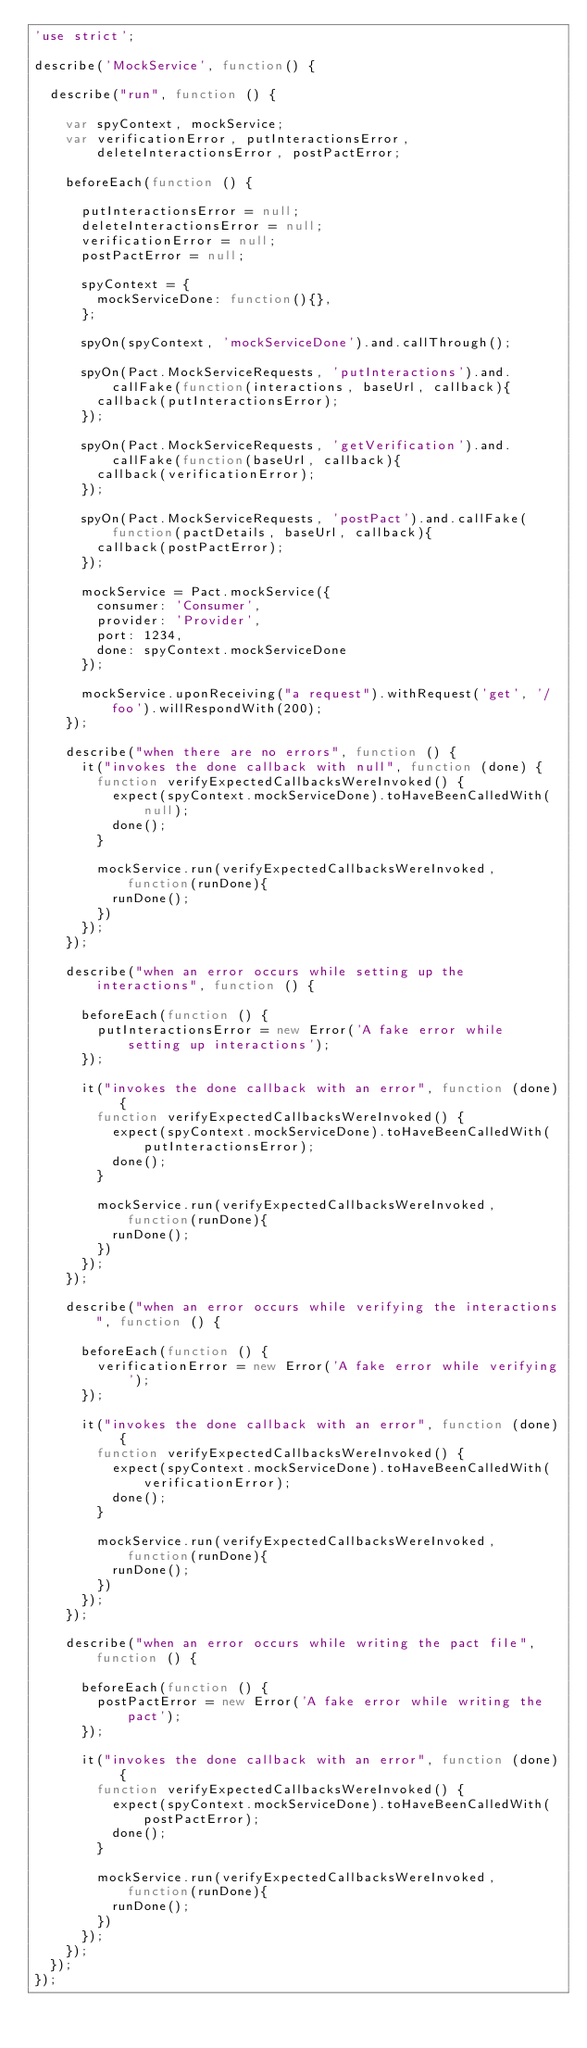Convert code to text. <code><loc_0><loc_0><loc_500><loc_500><_JavaScript_>'use strict';

describe('MockService', function() {

  describe("run", function () {

    var spyContext, mockService;
    var verificationError, putInteractionsError, deleteInteractionsError, postPactError;

    beforeEach(function () {

      putInteractionsError = null;
      deleteInteractionsError = null;
      verificationError = null;
      postPactError = null;

      spyContext = {
        mockServiceDone: function(){},
      };

      spyOn(spyContext, 'mockServiceDone').and.callThrough();

      spyOn(Pact.MockServiceRequests, 'putInteractions').and.callFake(function(interactions, baseUrl, callback){
        callback(putInteractionsError);
      });

      spyOn(Pact.MockServiceRequests, 'getVerification').and.callFake(function(baseUrl, callback){
        callback(verificationError);
      });

      spyOn(Pact.MockServiceRequests, 'postPact').and.callFake(function(pactDetails, baseUrl, callback){
        callback(postPactError);
      });

      mockService = Pact.mockService({
        consumer: 'Consumer',
        provider: 'Provider',
        port: 1234,
        done: spyContext.mockServiceDone
      });

      mockService.uponReceiving("a request").withRequest('get', '/foo').willRespondWith(200);
    });

    describe("when there are no errors", function () {
      it("invokes the done callback with null", function (done) {
        function verifyExpectedCallbacksWereInvoked() {
          expect(spyContext.mockServiceDone).toHaveBeenCalledWith(null);
          done();
        }

        mockService.run(verifyExpectedCallbacksWereInvoked, function(runDone){
          runDone();
        })
      });
    });

    describe("when an error occurs while setting up the interactions", function () {

      beforeEach(function () {
        putInteractionsError = new Error('A fake error while setting up interactions');
      });

      it("invokes the done callback with an error", function (done) {
        function verifyExpectedCallbacksWereInvoked() {
          expect(spyContext.mockServiceDone).toHaveBeenCalledWith(putInteractionsError);
          done();
        }

        mockService.run(verifyExpectedCallbacksWereInvoked, function(runDone){
          runDone();
        })
      });
    });

    describe("when an error occurs while verifying the interactions", function () {

      beforeEach(function () {
        verificationError = new Error('A fake error while verifying');
      });

      it("invokes the done callback with an error", function (done) {
        function verifyExpectedCallbacksWereInvoked() {
          expect(spyContext.mockServiceDone).toHaveBeenCalledWith(verificationError);
          done();
        }

        mockService.run(verifyExpectedCallbacksWereInvoked, function(runDone){
          runDone();
        })
      });
    });

    describe("when an error occurs while writing the pact file", function () {

      beforeEach(function () {
        postPactError = new Error('A fake error while writing the pact');
      });

      it("invokes the done callback with an error", function (done) {
        function verifyExpectedCallbacksWereInvoked() {
          expect(spyContext.mockServiceDone).toHaveBeenCalledWith(postPactError);
          done();
        }

        mockService.run(verifyExpectedCallbacksWereInvoked, function(runDone){
          runDone();
        })
      });
    });
  });
});
</code> 